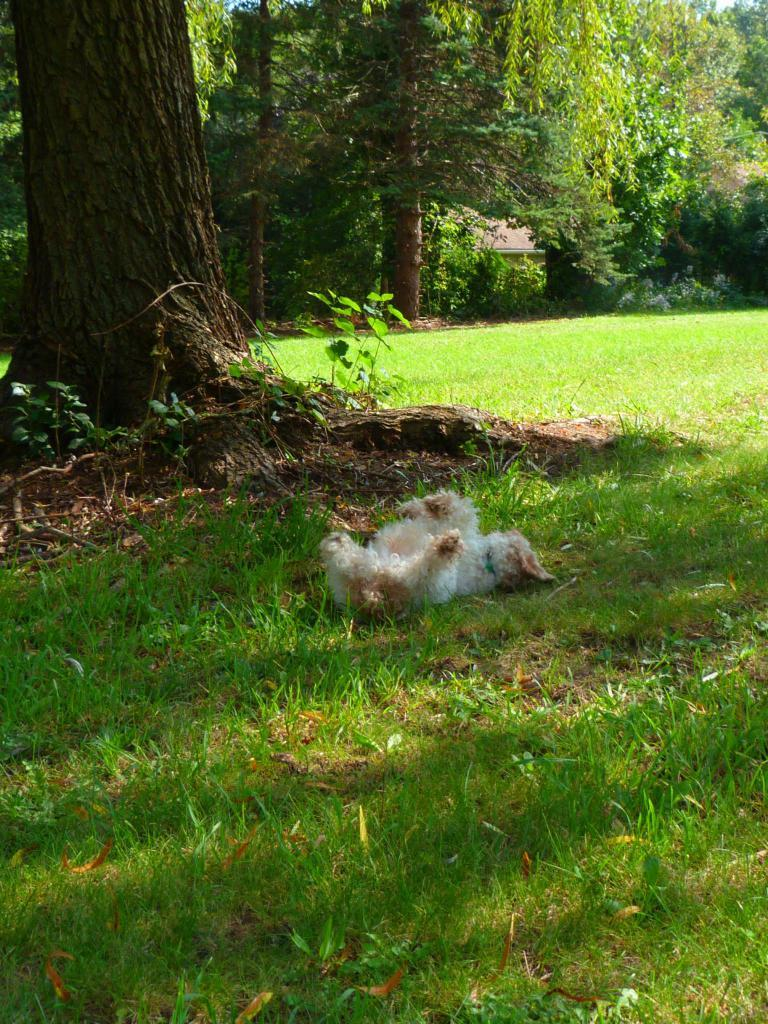What type of animal can be seen in the image? There is an animal in the image, but the specific type cannot be determined from the provided facts. What is the animal doing in the image? The animal is lying on the grass. What can be seen in the background of the image? There are trees visible in the background of the image. How much money is the animal holding in the image? There is no money present in the image, as it features an animal lying on the grass with trees in the background. 